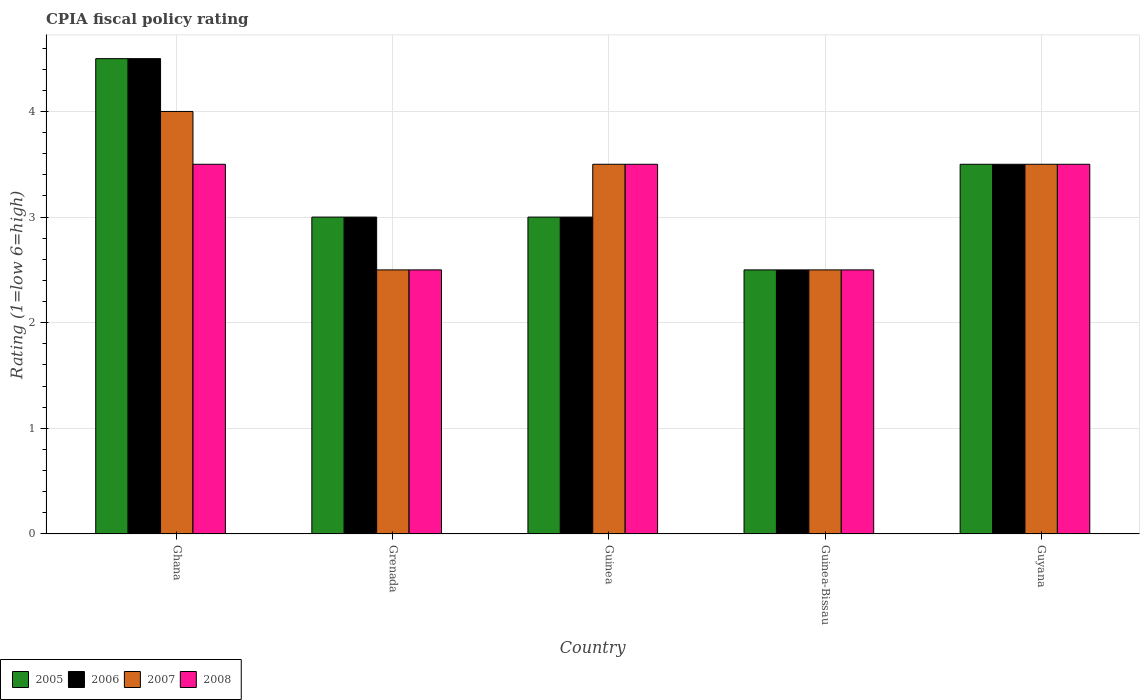How many different coloured bars are there?
Keep it short and to the point. 4. How many groups of bars are there?
Offer a very short reply. 5. What is the label of the 5th group of bars from the left?
Provide a short and direct response. Guyana. What is the CPIA rating in 2006 in Ghana?
Provide a short and direct response. 4.5. Across all countries, what is the minimum CPIA rating in 2005?
Your answer should be compact. 2.5. In which country was the CPIA rating in 2005 maximum?
Offer a terse response. Ghana. In which country was the CPIA rating in 2008 minimum?
Ensure brevity in your answer.  Grenada. What is the total CPIA rating in 2008 in the graph?
Make the answer very short. 15.5. What is the difference between the CPIA rating in 2008 in Guyana and the CPIA rating in 2006 in Guinea-Bissau?
Keep it short and to the point. 1. What is the average CPIA rating in 2006 per country?
Provide a succinct answer. 3.3. What is the ratio of the CPIA rating in 2005 in Ghana to that in Grenada?
Ensure brevity in your answer.  1.5. Is the difference between the CPIA rating in 2007 in Ghana and Guyana greater than the difference between the CPIA rating in 2008 in Ghana and Guyana?
Provide a succinct answer. Yes. What is the difference between the highest and the lowest CPIA rating in 2008?
Your response must be concise. 1. In how many countries, is the CPIA rating in 2005 greater than the average CPIA rating in 2005 taken over all countries?
Make the answer very short. 2. Is it the case that in every country, the sum of the CPIA rating in 2005 and CPIA rating in 2007 is greater than the sum of CPIA rating in 2008 and CPIA rating in 2006?
Offer a terse response. No. What does the 3rd bar from the left in Guinea-Bissau represents?
Your response must be concise. 2007. What does the 2nd bar from the right in Guyana represents?
Your response must be concise. 2007. How many bars are there?
Ensure brevity in your answer.  20. What is the difference between two consecutive major ticks on the Y-axis?
Keep it short and to the point. 1. Are the values on the major ticks of Y-axis written in scientific E-notation?
Offer a very short reply. No. Does the graph contain any zero values?
Offer a very short reply. No. Does the graph contain grids?
Your answer should be compact. Yes. Where does the legend appear in the graph?
Keep it short and to the point. Bottom left. How are the legend labels stacked?
Provide a short and direct response. Horizontal. What is the title of the graph?
Your answer should be compact. CPIA fiscal policy rating. What is the label or title of the X-axis?
Your answer should be compact. Country. What is the Rating (1=low 6=high) of 2005 in Ghana?
Offer a terse response. 4.5. What is the Rating (1=low 6=high) in 2006 in Ghana?
Your answer should be compact. 4.5. What is the Rating (1=low 6=high) in 2007 in Ghana?
Provide a succinct answer. 4. What is the Rating (1=low 6=high) in 2005 in Grenada?
Keep it short and to the point. 3. What is the Rating (1=low 6=high) in 2007 in Grenada?
Provide a succinct answer. 2.5. What is the Rating (1=low 6=high) of 2008 in Grenada?
Your answer should be very brief. 2.5. What is the Rating (1=low 6=high) in 2005 in Guinea?
Offer a very short reply. 3. What is the Rating (1=low 6=high) of 2007 in Guinea?
Provide a short and direct response. 3.5. What is the Rating (1=low 6=high) of 2005 in Guinea-Bissau?
Your answer should be very brief. 2.5. What is the Rating (1=low 6=high) of 2006 in Guinea-Bissau?
Your answer should be very brief. 2.5. What is the Rating (1=low 6=high) in 2008 in Guinea-Bissau?
Provide a short and direct response. 2.5. What is the Rating (1=low 6=high) of 2008 in Guyana?
Your answer should be very brief. 3.5. Across all countries, what is the maximum Rating (1=low 6=high) of 2005?
Offer a terse response. 4.5. Across all countries, what is the maximum Rating (1=low 6=high) in 2006?
Offer a very short reply. 4.5. Across all countries, what is the maximum Rating (1=low 6=high) in 2007?
Give a very brief answer. 4. Across all countries, what is the maximum Rating (1=low 6=high) in 2008?
Ensure brevity in your answer.  3.5. Across all countries, what is the minimum Rating (1=low 6=high) of 2005?
Your answer should be compact. 2.5. Across all countries, what is the minimum Rating (1=low 6=high) of 2006?
Your answer should be compact. 2.5. Across all countries, what is the minimum Rating (1=low 6=high) of 2007?
Make the answer very short. 2.5. Across all countries, what is the minimum Rating (1=low 6=high) of 2008?
Make the answer very short. 2.5. What is the total Rating (1=low 6=high) of 2006 in the graph?
Provide a short and direct response. 16.5. What is the total Rating (1=low 6=high) in 2007 in the graph?
Offer a very short reply. 16. What is the difference between the Rating (1=low 6=high) in 2005 in Ghana and that in Grenada?
Keep it short and to the point. 1.5. What is the difference between the Rating (1=low 6=high) of 2005 in Ghana and that in Guinea?
Your response must be concise. 1.5. What is the difference between the Rating (1=low 6=high) in 2006 in Ghana and that in Guinea?
Provide a succinct answer. 1.5. What is the difference between the Rating (1=low 6=high) in 2008 in Ghana and that in Guinea?
Your answer should be very brief. 0. What is the difference between the Rating (1=low 6=high) in 2005 in Ghana and that in Guinea-Bissau?
Keep it short and to the point. 2. What is the difference between the Rating (1=low 6=high) of 2007 in Ghana and that in Guinea-Bissau?
Give a very brief answer. 1.5. What is the difference between the Rating (1=low 6=high) in 2008 in Ghana and that in Guinea-Bissau?
Offer a very short reply. 1. What is the difference between the Rating (1=low 6=high) of 2005 in Ghana and that in Guyana?
Give a very brief answer. 1. What is the difference between the Rating (1=low 6=high) in 2007 in Ghana and that in Guyana?
Provide a succinct answer. 0.5. What is the difference between the Rating (1=low 6=high) in 2008 in Ghana and that in Guyana?
Provide a succinct answer. 0. What is the difference between the Rating (1=low 6=high) of 2007 in Grenada and that in Guinea?
Offer a very short reply. -1. What is the difference between the Rating (1=low 6=high) of 2007 in Grenada and that in Guinea-Bissau?
Offer a terse response. 0. What is the difference between the Rating (1=low 6=high) of 2005 in Guinea and that in Guinea-Bissau?
Your answer should be compact. 0.5. What is the difference between the Rating (1=low 6=high) of 2006 in Guinea and that in Guinea-Bissau?
Provide a short and direct response. 0.5. What is the difference between the Rating (1=low 6=high) of 2005 in Guinea and that in Guyana?
Provide a succinct answer. -0.5. What is the difference between the Rating (1=low 6=high) of 2006 in Guinea and that in Guyana?
Ensure brevity in your answer.  -0.5. What is the difference between the Rating (1=low 6=high) in 2007 in Guinea and that in Guyana?
Your answer should be compact. 0. What is the difference between the Rating (1=low 6=high) of 2008 in Guinea and that in Guyana?
Keep it short and to the point. 0. What is the difference between the Rating (1=low 6=high) in 2005 in Guinea-Bissau and that in Guyana?
Offer a terse response. -1. What is the difference between the Rating (1=low 6=high) in 2007 in Guinea-Bissau and that in Guyana?
Give a very brief answer. -1. What is the difference between the Rating (1=low 6=high) in 2008 in Guinea-Bissau and that in Guyana?
Keep it short and to the point. -1. What is the difference between the Rating (1=low 6=high) of 2005 in Ghana and the Rating (1=low 6=high) of 2006 in Grenada?
Offer a terse response. 1.5. What is the difference between the Rating (1=low 6=high) in 2006 in Ghana and the Rating (1=low 6=high) in 2008 in Grenada?
Provide a succinct answer. 2. What is the difference between the Rating (1=low 6=high) of 2007 in Ghana and the Rating (1=low 6=high) of 2008 in Grenada?
Provide a short and direct response. 1.5. What is the difference between the Rating (1=low 6=high) of 2006 in Ghana and the Rating (1=low 6=high) of 2008 in Guinea?
Your answer should be compact. 1. What is the difference between the Rating (1=low 6=high) in 2007 in Ghana and the Rating (1=low 6=high) in 2008 in Guinea?
Offer a very short reply. 0.5. What is the difference between the Rating (1=low 6=high) in 2005 in Ghana and the Rating (1=low 6=high) in 2006 in Guinea-Bissau?
Make the answer very short. 2. What is the difference between the Rating (1=low 6=high) of 2005 in Ghana and the Rating (1=low 6=high) of 2008 in Guinea-Bissau?
Ensure brevity in your answer.  2. What is the difference between the Rating (1=low 6=high) in 2006 in Ghana and the Rating (1=low 6=high) in 2007 in Guinea-Bissau?
Offer a very short reply. 2. What is the difference between the Rating (1=low 6=high) in 2005 in Ghana and the Rating (1=low 6=high) in 2006 in Guyana?
Your answer should be very brief. 1. What is the difference between the Rating (1=low 6=high) in 2005 in Ghana and the Rating (1=low 6=high) in 2007 in Guyana?
Keep it short and to the point. 1. What is the difference between the Rating (1=low 6=high) of 2006 in Ghana and the Rating (1=low 6=high) of 2007 in Guyana?
Keep it short and to the point. 1. What is the difference between the Rating (1=low 6=high) in 2005 in Grenada and the Rating (1=low 6=high) in 2008 in Guinea?
Make the answer very short. -0.5. What is the difference between the Rating (1=low 6=high) in 2006 in Grenada and the Rating (1=low 6=high) in 2007 in Guinea?
Ensure brevity in your answer.  -0.5. What is the difference between the Rating (1=low 6=high) of 2006 in Grenada and the Rating (1=low 6=high) of 2008 in Guinea?
Provide a short and direct response. -0.5. What is the difference between the Rating (1=low 6=high) of 2005 in Grenada and the Rating (1=low 6=high) of 2007 in Guinea-Bissau?
Ensure brevity in your answer.  0.5. What is the difference between the Rating (1=low 6=high) of 2006 in Grenada and the Rating (1=low 6=high) of 2008 in Guinea-Bissau?
Provide a short and direct response. 0.5. What is the difference between the Rating (1=low 6=high) of 2005 in Grenada and the Rating (1=low 6=high) of 2007 in Guyana?
Give a very brief answer. -0.5. What is the difference between the Rating (1=low 6=high) in 2005 in Grenada and the Rating (1=low 6=high) in 2008 in Guyana?
Offer a terse response. -0.5. What is the difference between the Rating (1=low 6=high) of 2006 in Grenada and the Rating (1=low 6=high) of 2007 in Guyana?
Provide a short and direct response. -0.5. What is the difference between the Rating (1=low 6=high) in 2007 in Grenada and the Rating (1=low 6=high) in 2008 in Guyana?
Your answer should be compact. -1. What is the difference between the Rating (1=low 6=high) in 2005 in Guinea and the Rating (1=low 6=high) in 2006 in Guinea-Bissau?
Make the answer very short. 0.5. What is the difference between the Rating (1=low 6=high) of 2006 in Guinea and the Rating (1=low 6=high) of 2007 in Guinea-Bissau?
Offer a very short reply. 0.5. What is the difference between the Rating (1=low 6=high) of 2007 in Guinea and the Rating (1=low 6=high) of 2008 in Guinea-Bissau?
Keep it short and to the point. 1. What is the difference between the Rating (1=low 6=high) of 2005 in Guinea and the Rating (1=low 6=high) of 2008 in Guyana?
Your answer should be very brief. -0.5. What is the difference between the Rating (1=low 6=high) of 2006 in Guinea and the Rating (1=low 6=high) of 2008 in Guyana?
Offer a very short reply. -0.5. What is the difference between the Rating (1=low 6=high) in 2007 in Guinea and the Rating (1=low 6=high) in 2008 in Guyana?
Provide a short and direct response. 0. What is the difference between the Rating (1=low 6=high) of 2005 in Guinea-Bissau and the Rating (1=low 6=high) of 2008 in Guyana?
Make the answer very short. -1. What is the difference between the Rating (1=low 6=high) in 2006 in Guinea-Bissau and the Rating (1=low 6=high) in 2007 in Guyana?
Provide a short and direct response. -1. What is the difference between the Rating (1=low 6=high) of 2006 in Guinea-Bissau and the Rating (1=low 6=high) of 2008 in Guyana?
Give a very brief answer. -1. What is the difference between the Rating (1=low 6=high) in 2007 in Guinea-Bissau and the Rating (1=low 6=high) in 2008 in Guyana?
Your answer should be very brief. -1. What is the average Rating (1=low 6=high) of 2006 per country?
Your response must be concise. 3.3. What is the average Rating (1=low 6=high) of 2007 per country?
Offer a very short reply. 3.2. What is the average Rating (1=low 6=high) in 2008 per country?
Ensure brevity in your answer.  3.1. What is the difference between the Rating (1=low 6=high) of 2005 and Rating (1=low 6=high) of 2006 in Ghana?
Provide a short and direct response. 0. What is the difference between the Rating (1=low 6=high) of 2005 and Rating (1=low 6=high) of 2007 in Ghana?
Ensure brevity in your answer.  0.5. What is the difference between the Rating (1=low 6=high) in 2005 and Rating (1=low 6=high) in 2008 in Ghana?
Provide a short and direct response. 1. What is the difference between the Rating (1=low 6=high) in 2006 and Rating (1=low 6=high) in 2007 in Ghana?
Keep it short and to the point. 0.5. What is the difference between the Rating (1=low 6=high) of 2006 and Rating (1=low 6=high) of 2008 in Ghana?
Your answer should be very brief. 1. What is the difference between the Rating (1=low 6=high) of 2005 and Rating (1=low 6=high) of 2006 in Grenada?
Give a very brief answer. 0. What is the difference between the Rating (1=low 6=high) of 2005 and Rating (1=low 6=high) of 2007 in Grenada?
Ensure brevity in your answer.  0.5. What is the difference between the Rating (1=low 6=high) in 2006 and Rating (1=low 6=high) in 2008 in Guinea?
Your answer should be compact. -0.5. What is the difference between the Rating (1=low 6=high) in 2006 and Rating (1=low 6=high) in 2007 in Guinea-Bissau?
Provide a succinct answer. 0. What is the difference between the Rating (1=low 6=high) of 2006 and Rating (1=low 6=high) of 2008 in Guinea-Bissau?
Ensure brevity in your answer.  0. What is the difference between the Rating (1=low 6=high) in 2005 and Rating (1=low 6=high) in 2006 in Guyana?
Your response must be concise. 0. What is the difference between the Rating (1=low 6=high) in 2005 and Rating (1=low 6=high) in 2008 in Guyana?
Keep it short and to the point. 0. What is the difference between the Rating (1=low 6=high) in 2006 and Rating (1=low 6=high) in 2007 in Guyana?
Provide a short and direct response. 0. What is the difference between the Rating (1=low 6=high) of 2007 and Rating (1=low 6=high) of 2008 in Guyana?
Provide a succinct answer. 0. What is the ratio of the Rating (1=low 6=high) of 2005 in Ghana to that in Grenada?
Your response must be concise. 1.5. What is the ratio of the Rating (1=low 6=high) in 2006 in Ghana to that in Grenada?
Provide a short and direct response. 1.5. What is the ratio of the Rating (1=low 6=high) in 2007 in Ghana to that in Grenada?
Keep it short and to the point. 1.6. What is the ratio of the Rating (1=low 6=high) of 2005 in Ghana to that in Guinea-Bissau?
Make the answer very short. 1.8. What is the ratio of the Rating (1=low 6=high) in 2008 in Ghana to that in Guinea-Bissau?
Offer a terse response. 1.4. What is the ratio of the Rating (1=low 6=high) of 2006 in Ghana to that in Guyana?
Ensure brevity in your answer.  1.29. What is the ratio of the Rating (1=low 6=high) of 2008 in Ghana to that in Guyana?
Ensure brevity in your answer.  1. What is the ratio of the Rating (1=low 6=high) in 2005 in Grenada to that in Guinea?
Ensure brevity in your answer.  1. What is the ratio of the Rating (1=low 6=high) in 2007 in Grenada to that in Guinea?
Ensure brevity in your answer.  0.71. What is the ratio of the Rating (1=low 6=high) of 2005 in Grenada to that in Guinea-Bissau?
Make the answer very short. 1.2. What is the ratio of the Rating (1=low 6=high) of 2006 in Grenada to that in Guinea-Bissau?
Keep it short and to the point. 1.2. What is the ratio of the Rating (1=low 6=high) of 2007 in Guinea to that in Guinea-Bissau?
Provide a short and direct response. 1.4. What is the ratio of the Rating (1=low 6=high) in 2008 in Guinea to that in Guinea-Bissau?
Your response must be concise. 1.4. What is the ratio of the Rating (1=low 6=high) in 2005 in Guinea to that in Guyana?
Offer a terse response. 0.86. What is the ratio of the Rating (1=low 6=high) in 2007 in Guinea to that in Guyana?
Give a very brief answer. 1. What is the ratio of the Rating (1=low 6=high) in 2007 in Guinea-Bissau to that in Guyana?
Offer a very short reply. 0.71. What is the difference between the highest and the lowest Rating (1=low 6=high) in 2008?
Make the answer very short. 1. 